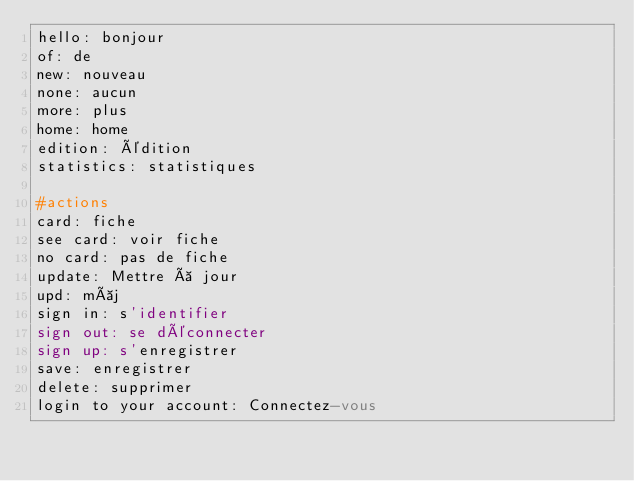<code> <loc_0><loc_0><loc_500><loc_500><_YAML_>hello: bonjour
of: de
new: nouveau
none: aucun
more: plus
home: home
edition: édition
statistics: statistiques

#actions
card: fiche
see card: voir fiche
no card: pas de fiche
update: Mettre à jour
upd: màj
sign in: s'identifier
sign out: se déconnecter
sign up: s'enregistrer
save: enregistrer
delete: supprimer
login to your account: Connectez-vous
</code> 